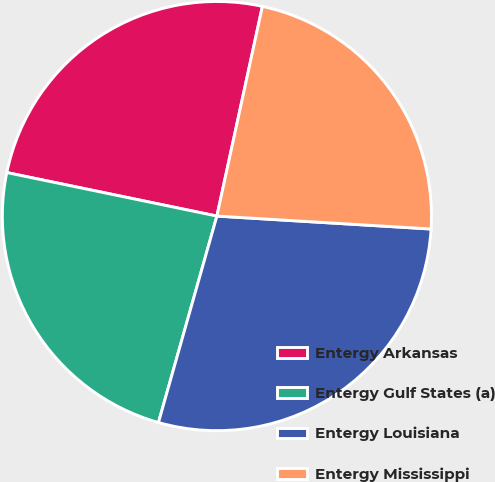Convert chart. <chart><loc_0><loc_0><loc_500><loc_500><pie_chart><fcel>Entergy Arkansas<fcel>Entergy Gulf States (a)<fcel>Entergy Louisiana<fcel>Entergy Mississippi<nl><fcel>25.15%<fcel>23.86%<fcel>28.43%<fcel>22.56%<nl></chart> 